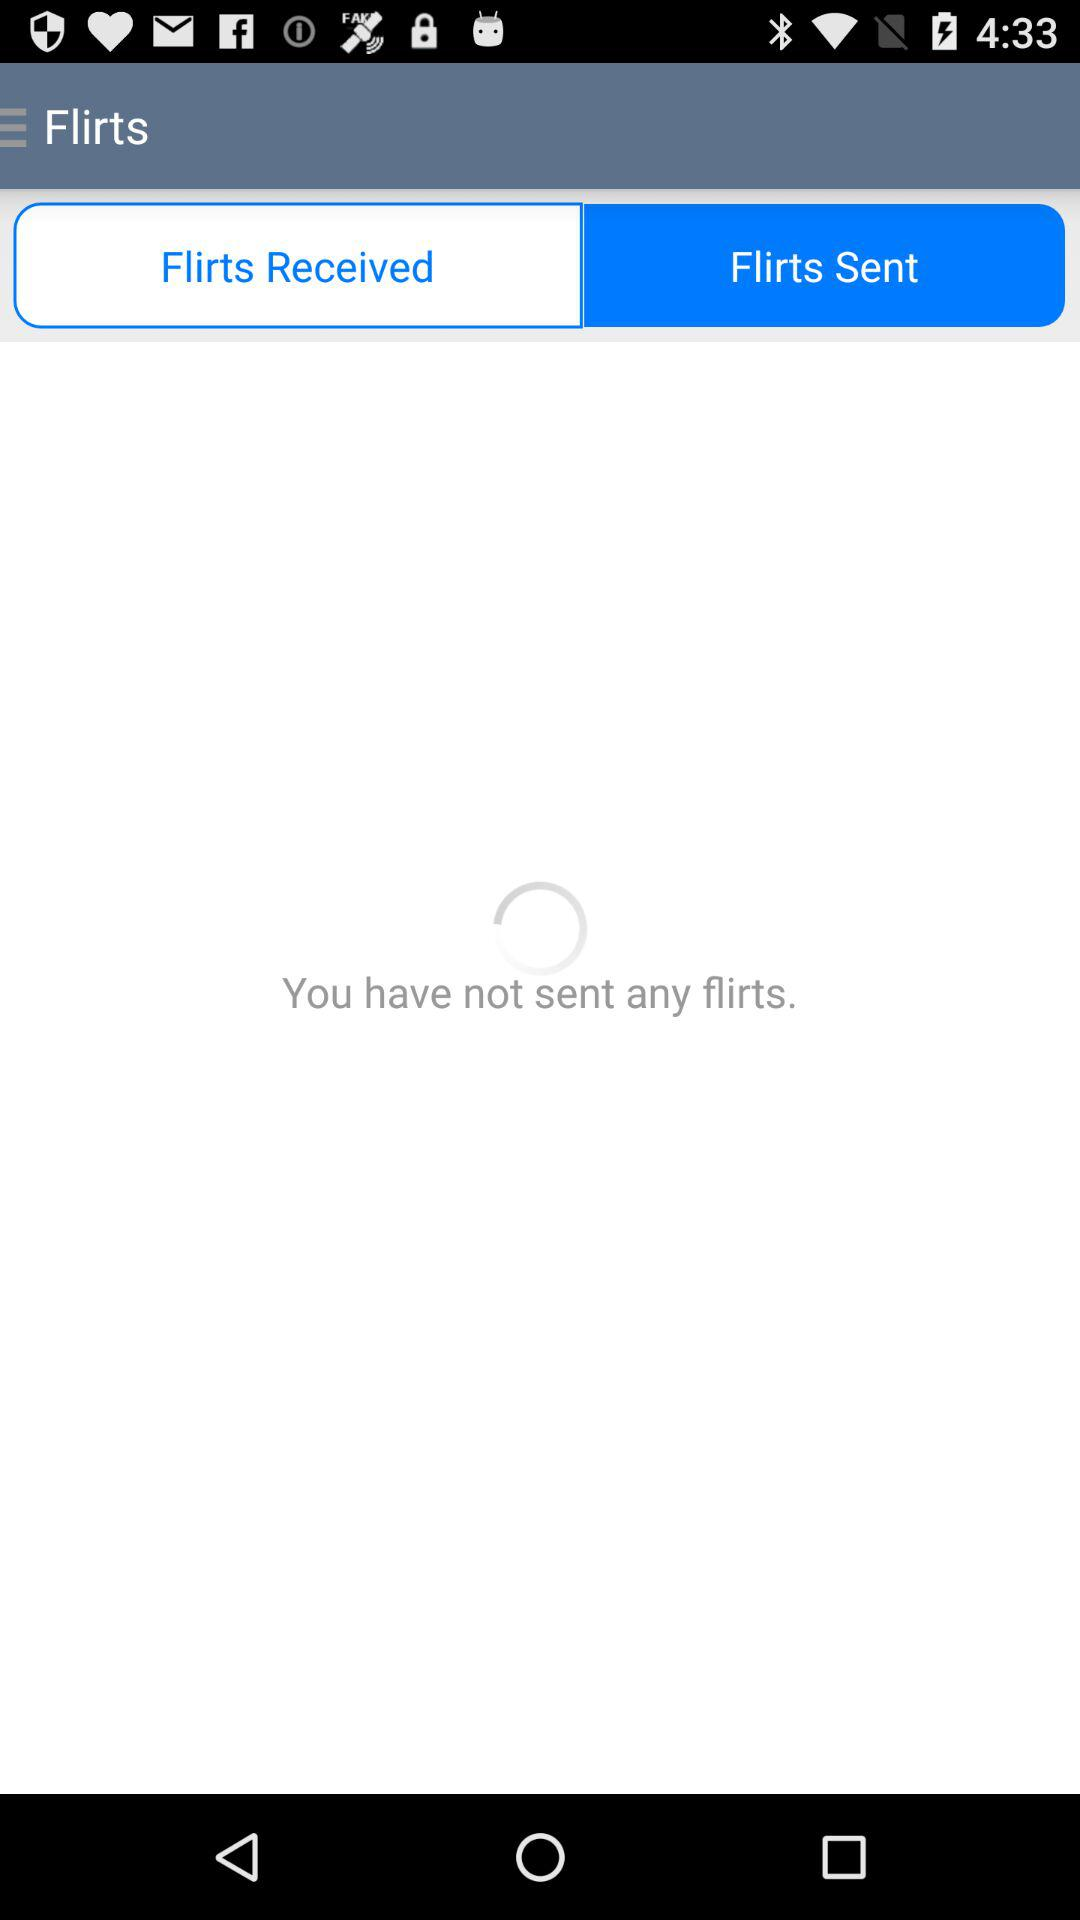How many flirts have I sent?
Answer the question using a single word or phrase. 0 